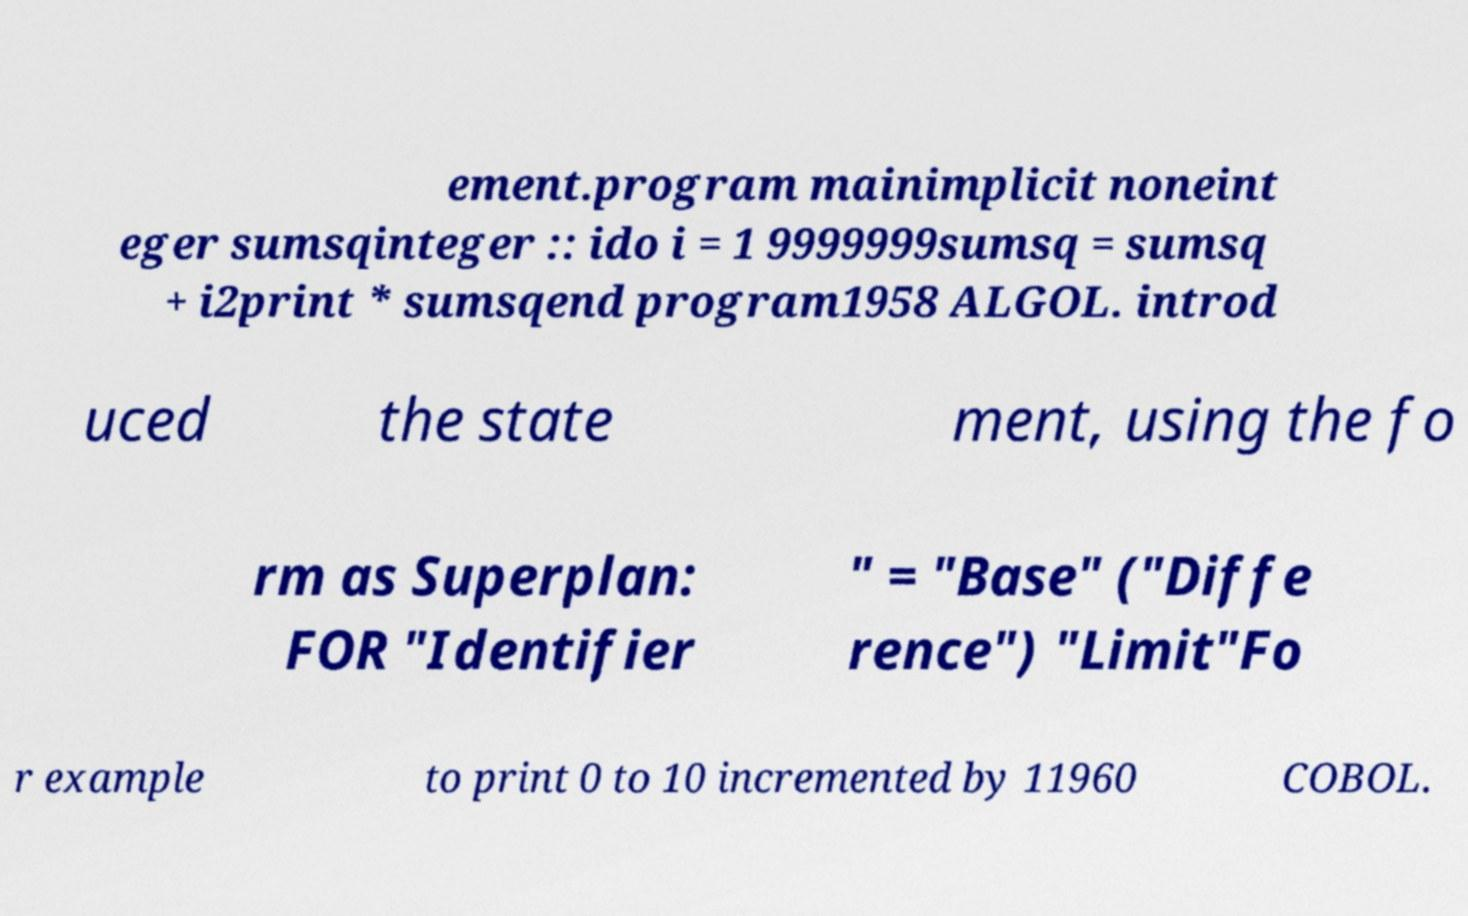Could you assist in decoding the text presented in this image and type it out clearly? ement.program mainimplicit noneint eger sumsqinteger :: ido i = 1 9999999sumsq = sumsq + i2print * sumsqend program1958 ALGOL. introd uced the state ment, using the fo rm as Superplan: FOR "Identifier " = "Base" ("Diffe rence") "Limit"Fo r example to print 0 to 10 incremented by 11960 COBOL. 